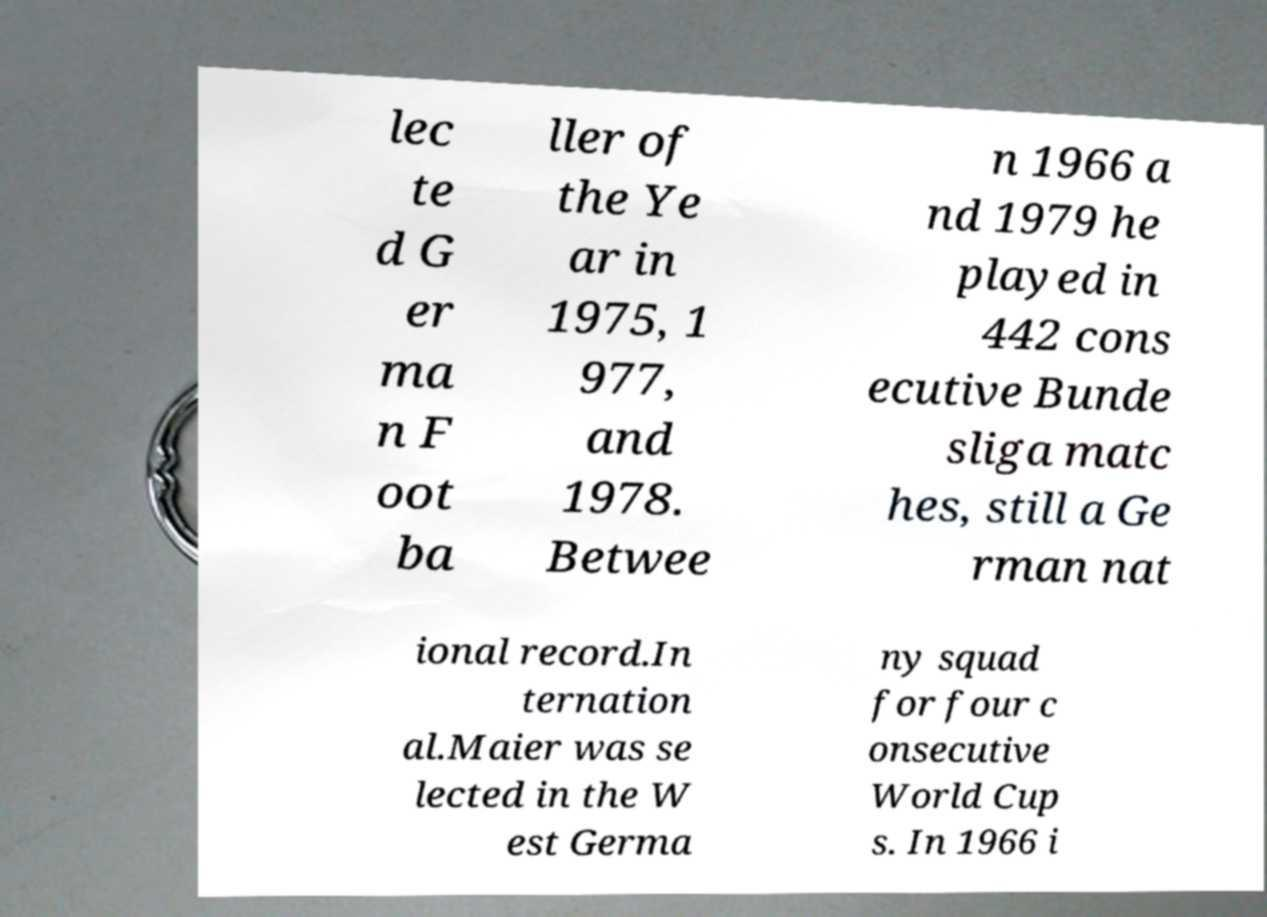There's text embedded in this image that I need extracted. Can you transcribe it verbatim? lec te d G er ma n F oot ba ller of the Ye ar in 1975, 1 977, and 1978. Betwee n 1966 a nd 1979 he played in 442 cons ecutive Bunde sliga matc hes, still a Ge rman nat ional record.In ternation al.Maier was se lected in the W est Germa ny squad for four c onsecutive World Cup s. In 1966 i 